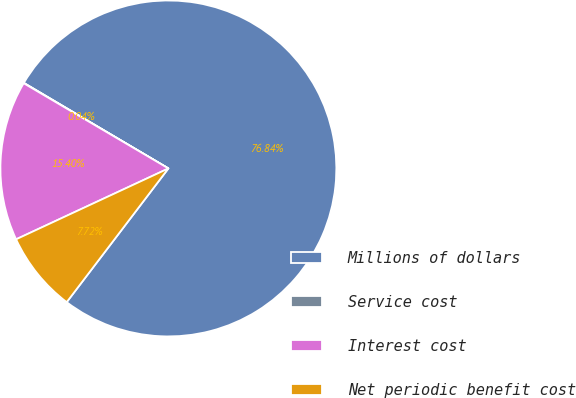Convert chart. <chart><loc_0><loc_0><loc_500><loc_500><pie_chart><fcel>Millions of dollars<fcel>Service cost<fcel>Interest cost<fcel>Net periodic benefit cost<nl><fcel>76.84%<fcel>0.04%<fcel>15.4%<fcel>7.72%<nl></chart> 